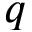Convert formula to latex. <formula><loc_0><loc_0><loc_500><loc_500>q</formula> 